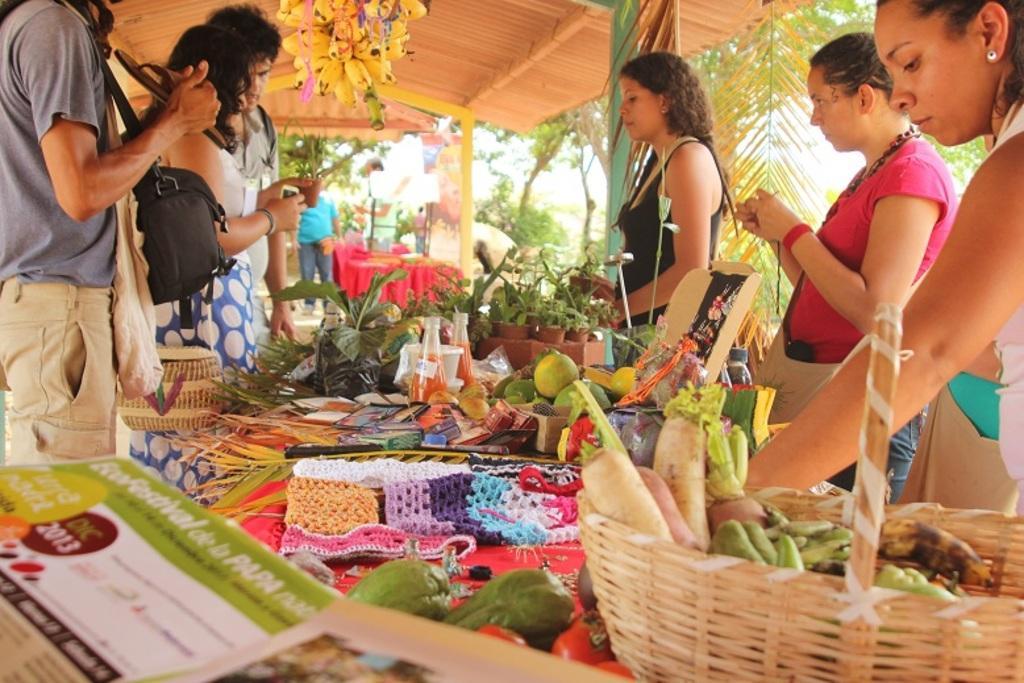How would you summarize this image in a sentence or two? Here in this picture we can see a group of people standing over a place and in between them we can see a table, on which we can see number of fruits and vegetables present in the baskets and at the top we can see a shed present and we can see bananas hanging over there and we can also see plants and trees present on the ground. 